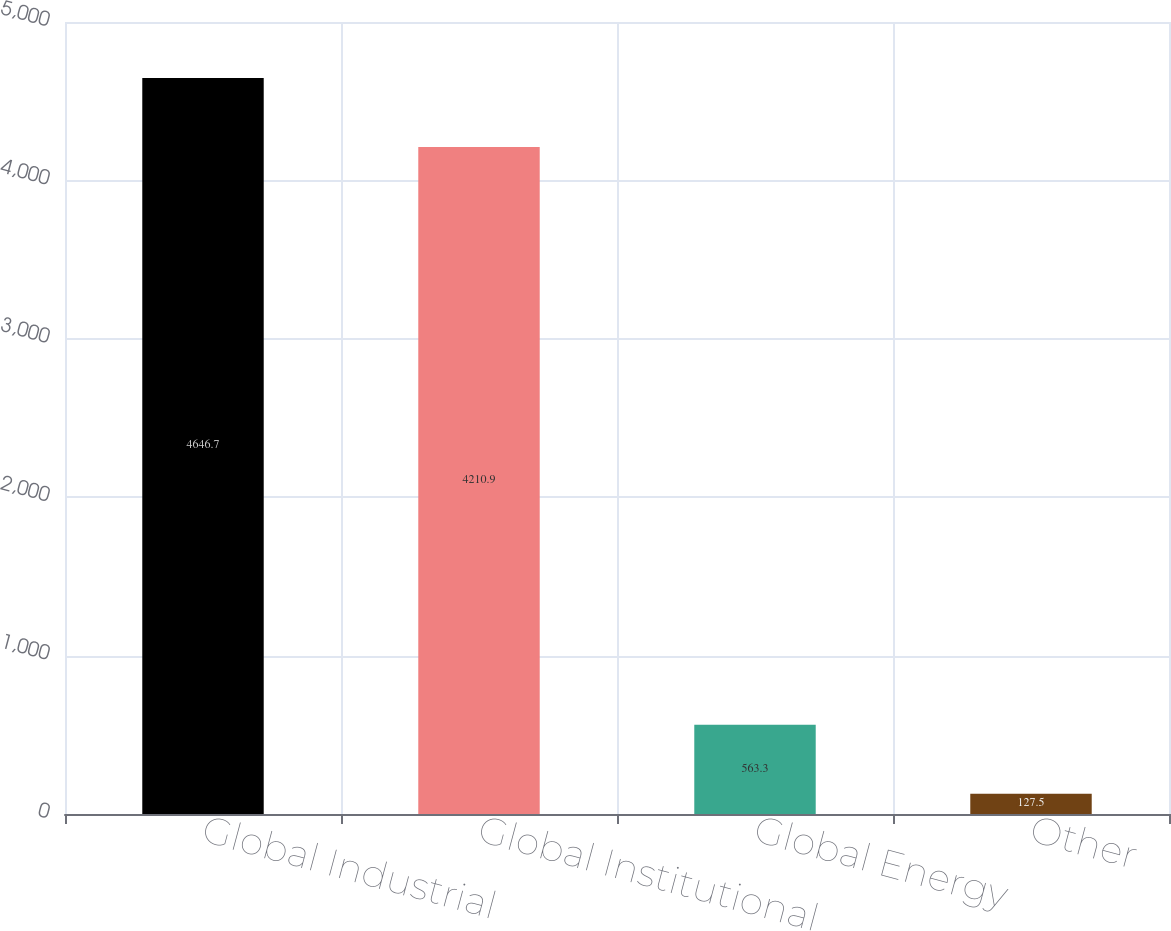Convert chart. <chart><loc_0><loc_0><loc_500><loc_500><bar_chart><fcel>Global Industrial<fcel>Global Institutional<fcel>Global Energy<fcel>Other<nl><fcel>4646.7<fcel>4210.9<fcel>563.3<fcel>127.5<nl></chart> 